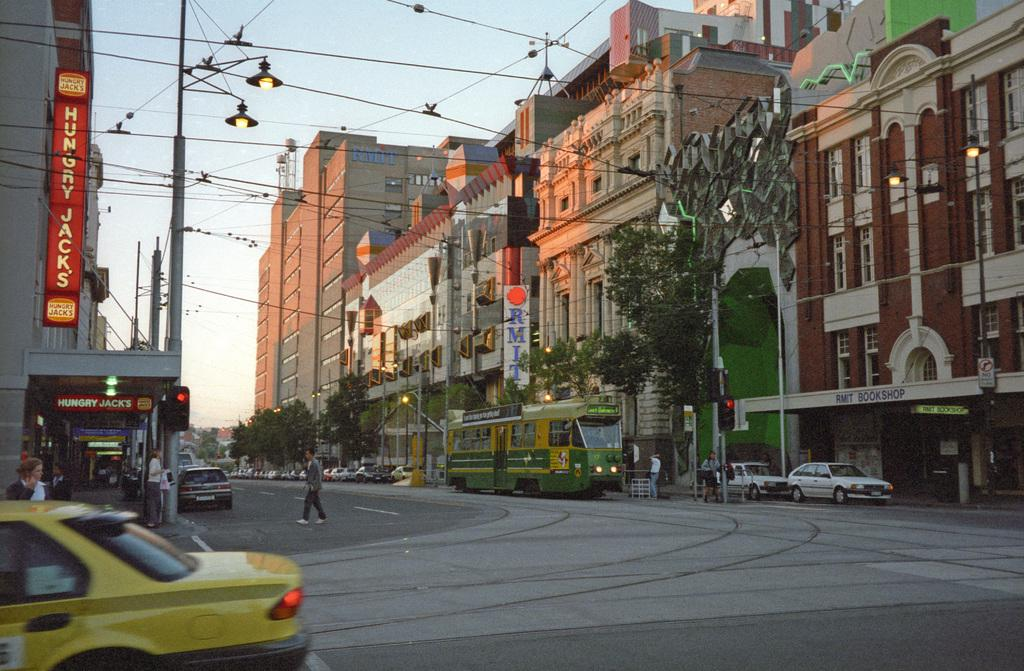Provide a one-sentence caption for the provided image. Hungry Jack's is the name glowing from the sign above the eatery. 